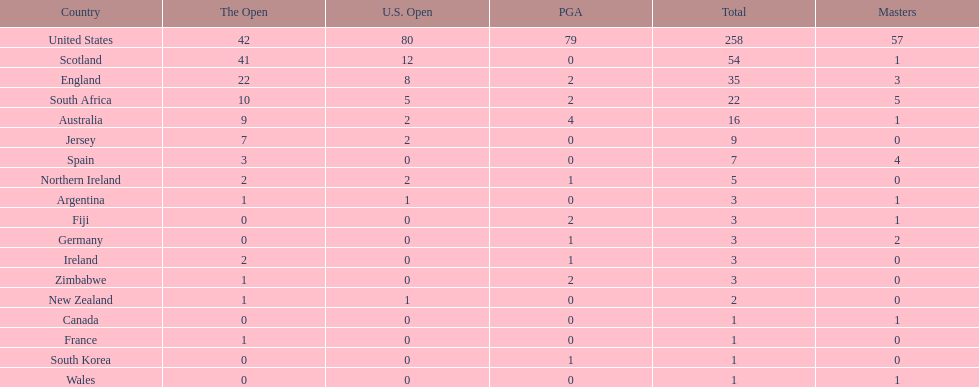How many u.s. open wins does fiji have? 0. 